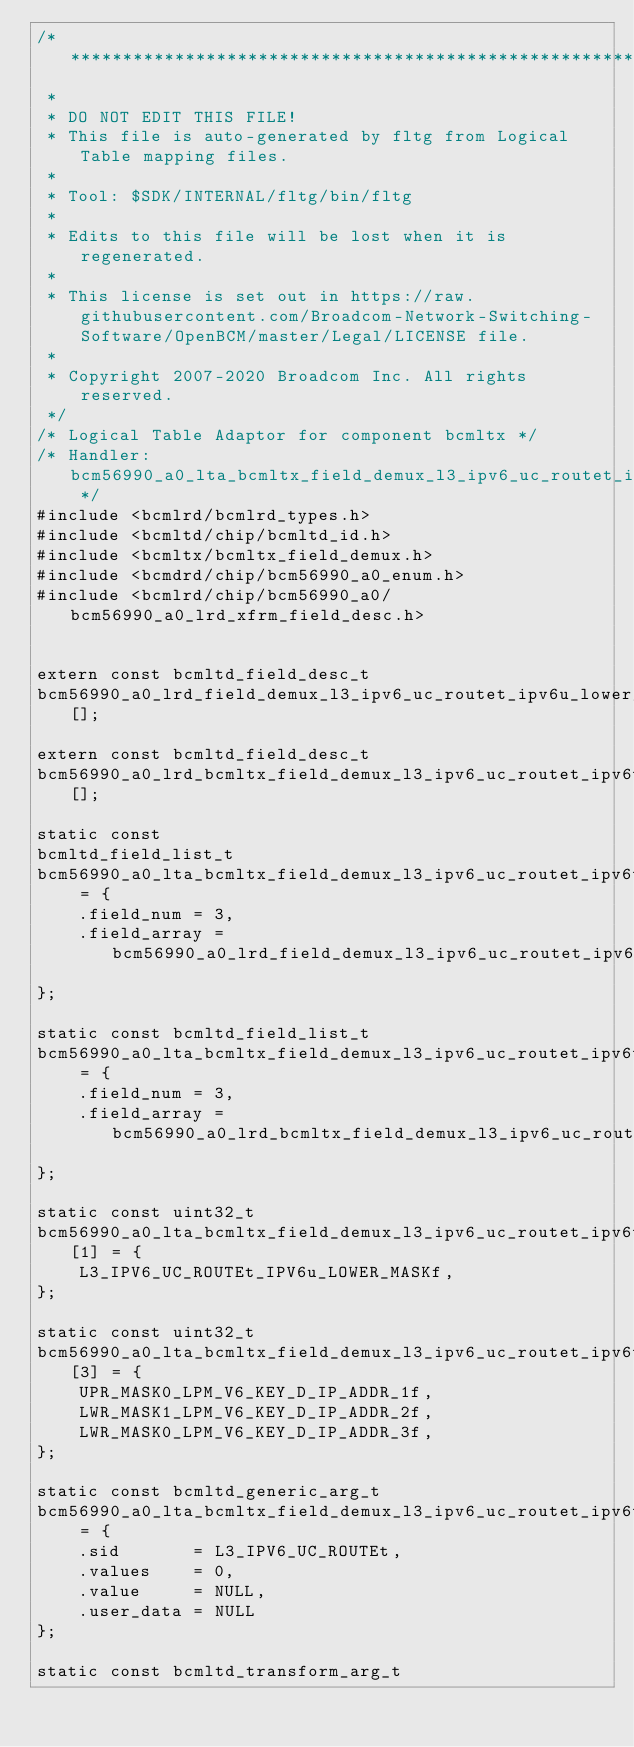Convert code to text. <code><loc_0><loc_0><loc_500><loc_500><_C_>/*******************************************************************************
 *
 * DO NOT EDIT THIS FILE!
 * This file is auto-generated by fltg from Logical Table mapping files.
 *
 * Tool: $SDK/INTERNAL/fltg/bin/fltg
 *
 * Edits to this file will be lost when it is regenerated.
 *
 * This license is set out in https://raw.githubusercontent.com/Broadcom-Network-Switching-Software/OpenBCM/master/Legal/LICENSE file.
 * 
 * Copyright 2007-2020 Broadcom Inc. All rights reserved.
 */
/* Logical Table Adaptor for component bcmltx */
/* Handler: bcm56990_a0_lta_bcmltx_field_demux_l3_ipv6_uc_routet_ipv6u_lower_maskf_0_xfrm_handler */
#include <bcmlrd/bcmlrd_types.h>
#include <bcmltd/chip/bcmltd_id.h>
#include <bcmltx/bcmltx_field_demux.h>
#include <bcmdrd/chip/bcm56990_a0_enum.h>
#include <bcmlrd/chip/bcm56990_a0/bcm56990_a0_lrd_xfrm_field_desc.h>


extern const bcmltd_field_desc_t
bcm56990_a0_lrd_field_demux_l3_ipv6_uc_routet_ipv6u_lower_maskf_0_src_field_desc_s0[];

extern const bcmltd_field_desc_t
bcm56990_a0_lrd_bcmltx_field_demux_l3_ipv6_uc_routet_ipv6u_lower_maskf_0_dst_field_desc_d0[];

static const
bcmltd_field_list_t
bcm56990_a0_lta_bcmltx_field_demux_l3_ipv6_uc_routet_ipv6u_lower_maskf_0_src_list_s0 = {
    .field_num = 3,
    .field_array = bcm56990_a0_lrd_field_demux_l3_ipv6_uc_routet_ipv6u_lower_maskf_0_src_field_desc_s0
};

static const bcmltd_field_list_t
bcm56990_a0_lta_bcmltx_field_demux_l3_ipv6_uc_routet_ipv6u_lower_maskf_0_dst_list_d0 = {
    .field_num = 3,
    .field_array = bcm56990_a0_lrd_bcmltx_field_demux_l3_ipv6_uc_routet_ipv6u_lower_maskf_0_dst_field_desc_d0
};

static const uint32_t
bcm56990_a0_lta_bcmltx_field_demux_l3_ipv6_uc_routet_ipv6u_lower_maskf_0_transform_src_s0[1] = {
    L3_IPV6_UC_ROUTEt_IPV6u_LOWER_MASKf,
};

static const uint32_t
bcm56990_a0_lta_bcmltx_field_demux_l3_ipv6_uc_routet_ipv6u_lower_maskf_0_transform_dst_d0[3] = {
    UPR_MASK0_LPM_V6_KEY_D_IP_ADDR_1f,
    LWR_MASK1_LPM_V6_KEY_D_IP_ADDR_2f,
    LWR_MASK0_LPM_V6_KEY_D_IP_ADDR_3f,
};

static const bcmltd_generic_arg_t
bcm56990_a0_lta_bcmltx_field_demux_l3_ipv6_uc_routet_ipv6u_lower_maskf_0_comp_data = {
    .sid       = L3_IPV6_UC_ROUTEt,
    .values    = 0,
    .value     = NULL,
    .user_data = NULL
};

static const bcmltd_transform_arg_t</code> 